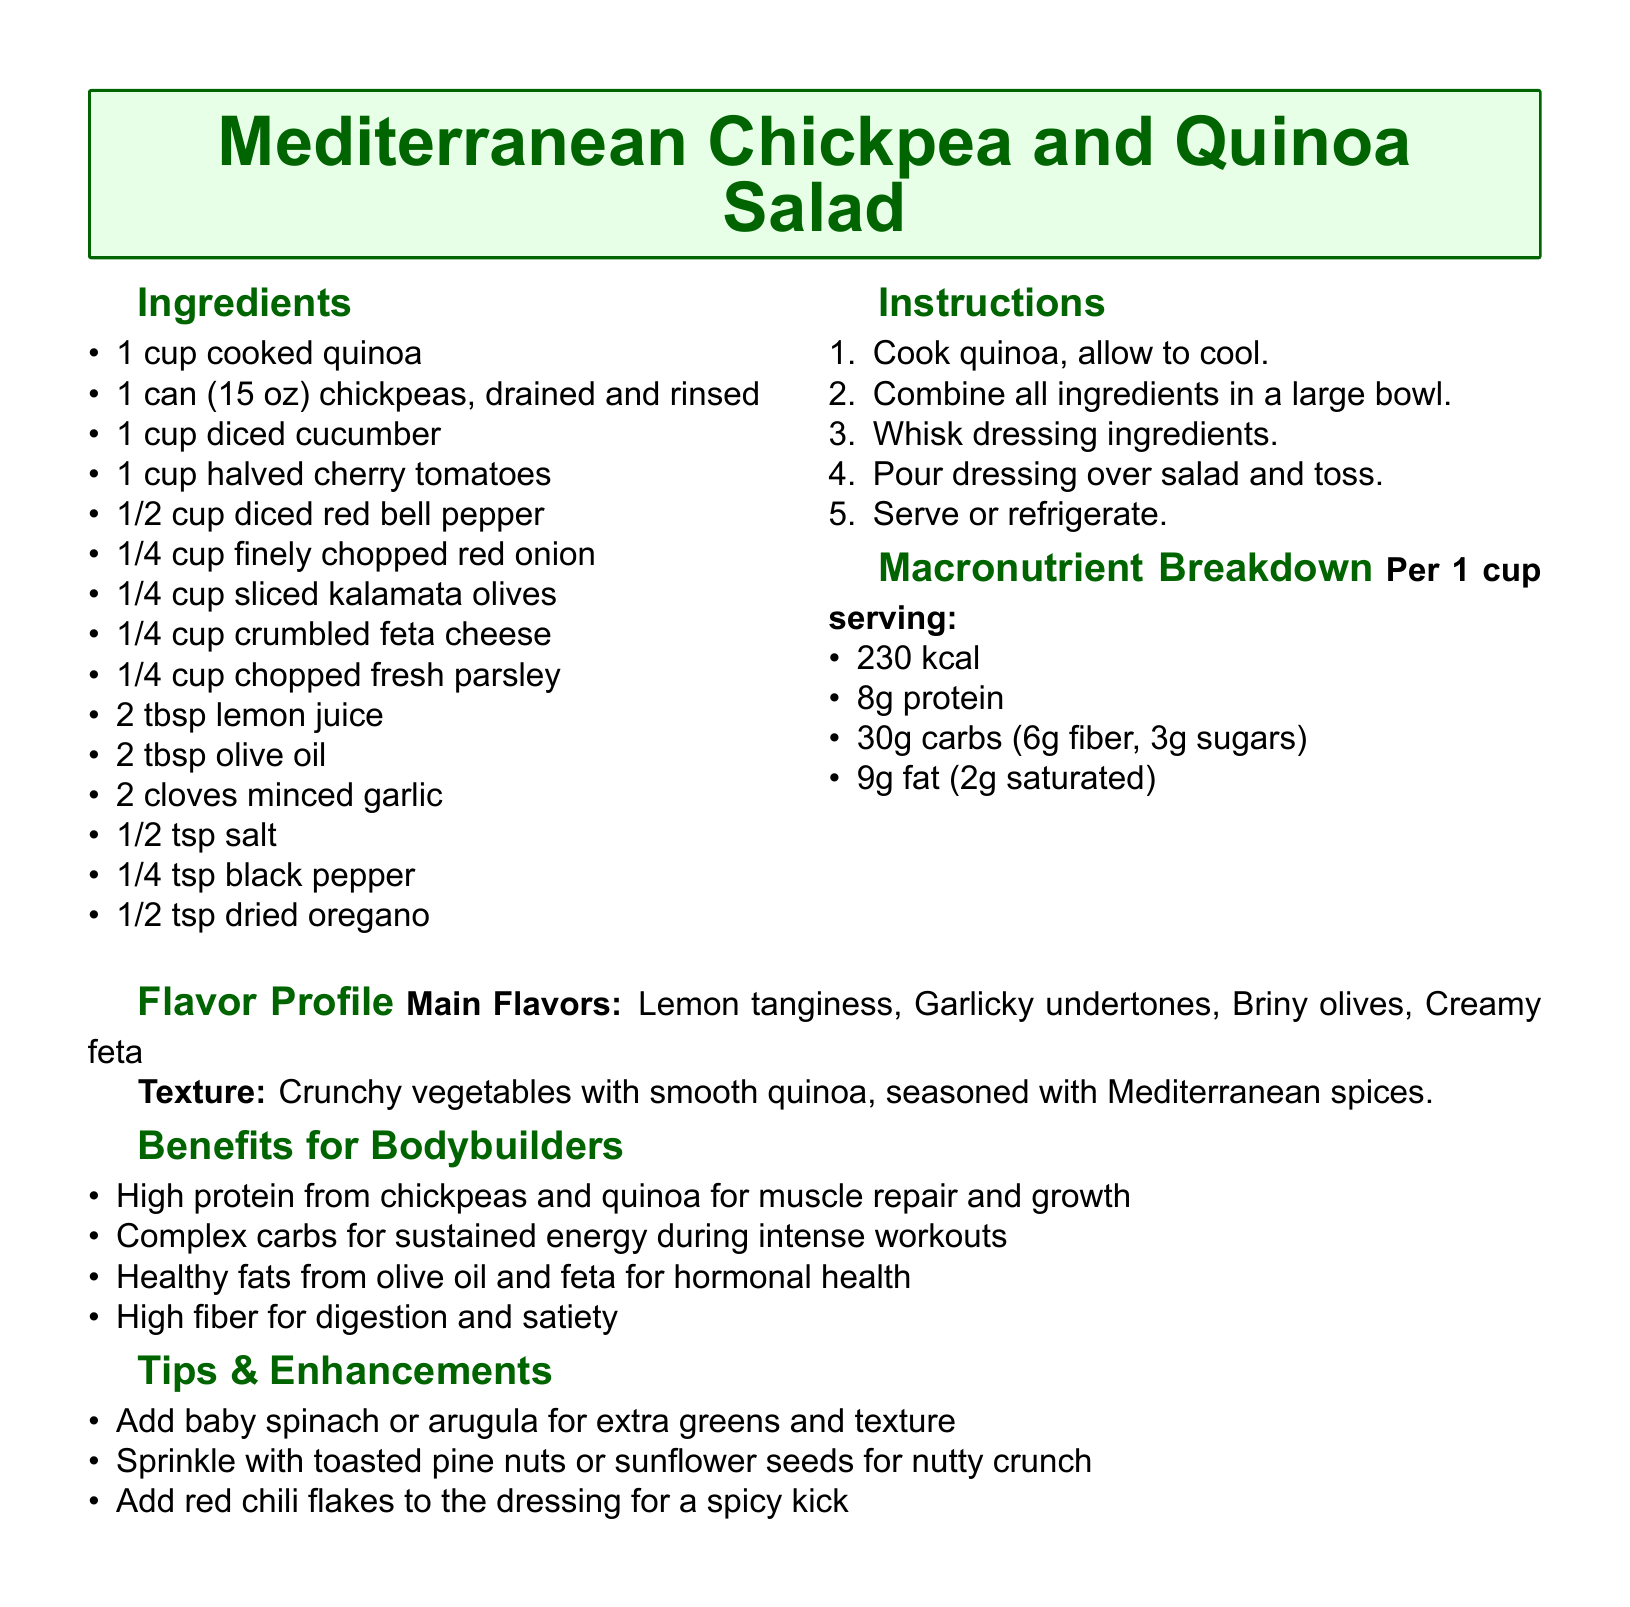what is the main ingredient of the salad? The main ingredient, as listed in the recipe, is chickpeas combined with quinoa.
Answer: chickpeas how many grams of protein are in one serving? The macronutrient breakdown specifies that there are 8 grams of protein per serving.
Answer: 8g what is the total calorie count per serving? The macronutrient breakdown lists the total calorie count for one serving as 230 kcal.
Answer: 230 kcal what type of cheese is used in the salad? The ingredients list explicitly mentions the use of feta cheese.
Answer: feta cheese what are the two main flavors of the salad? The flavor profile section identifies lemon tanginess and garlicky undertones as the main flavors.
Answer: lemon tanginess, garlicky undertones how much fiber is in one serving? The macronutrient breakdown includes that there are 6 grams of fiber per serving.
Answer: 6g which ingredient can be added for a spicy kick? The tips and enhancements section suggests adding red chili flakes for a spicy kick.
Answer: red chili flakes what vegetable can be added for extra greens? The tips mention adding baby spinach or arugula as options for extra greens.
Answer: baby spinach or arugula how many tablespoons of olive oil are needed? The ingredients list indicates that 2 tablespoons of olive oil are required.
Answer: 2 tbsp 